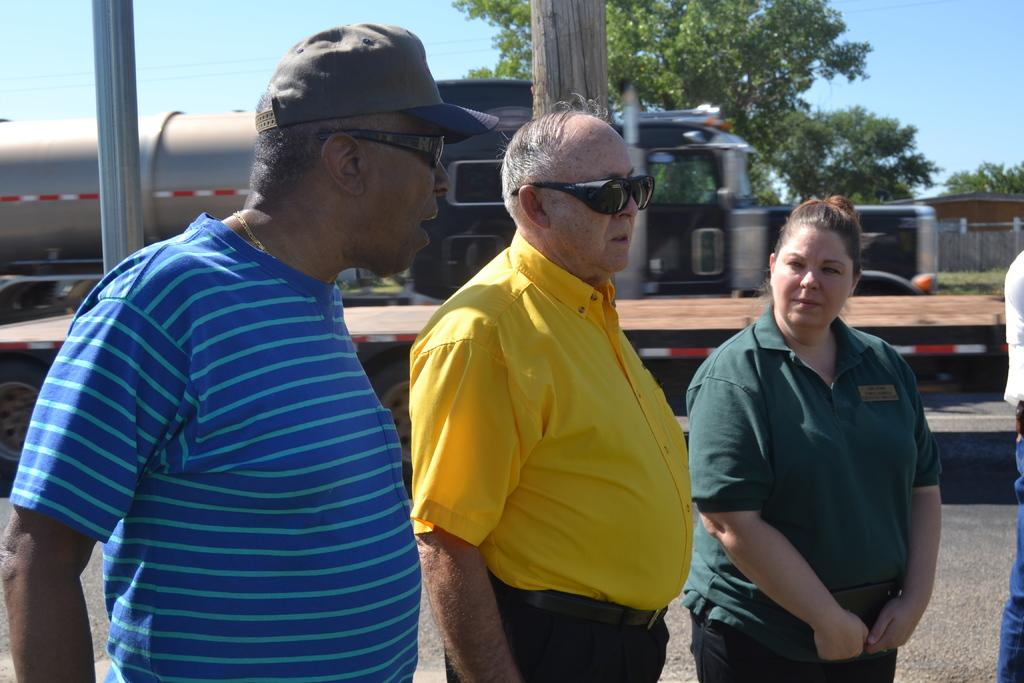How many people are present in the image? There are people in the image, but the exact number cannot be determined from the provided facts. What types of vehicles can be seen in the image? There are vehicles in the image, but the specific types cannot be determined from the provided facts. What are the poles used for in the image? The purpose of the poles in the image cannot be determined from the provided facts. What is visible in the background of the image? In the background of the image, there is a fence, trees, a house, grass, and the sky. What time is indicated on the clock in the image? There is no clock present in the image, so it is not possible to determine the time. 